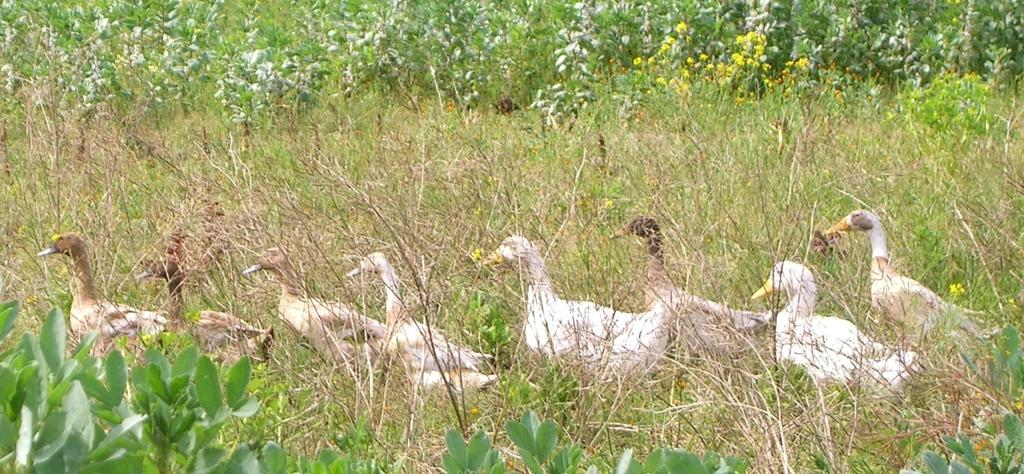What type of animals can be seen in the image? There are ducks in the image. What is located at the bottom of the image? There are plants at the bottom of the image. What can be seen in the background of the image? There are flowers and trees in the background of the image. What type of destruction can be seen in the image? There is no destruction present in the image; it features ducks, plants, flowers, and trees. What is the ducks using to cook in the image? There is no cooking or use of a pan in the image; it features ducks, plants, flowers, and trees. 